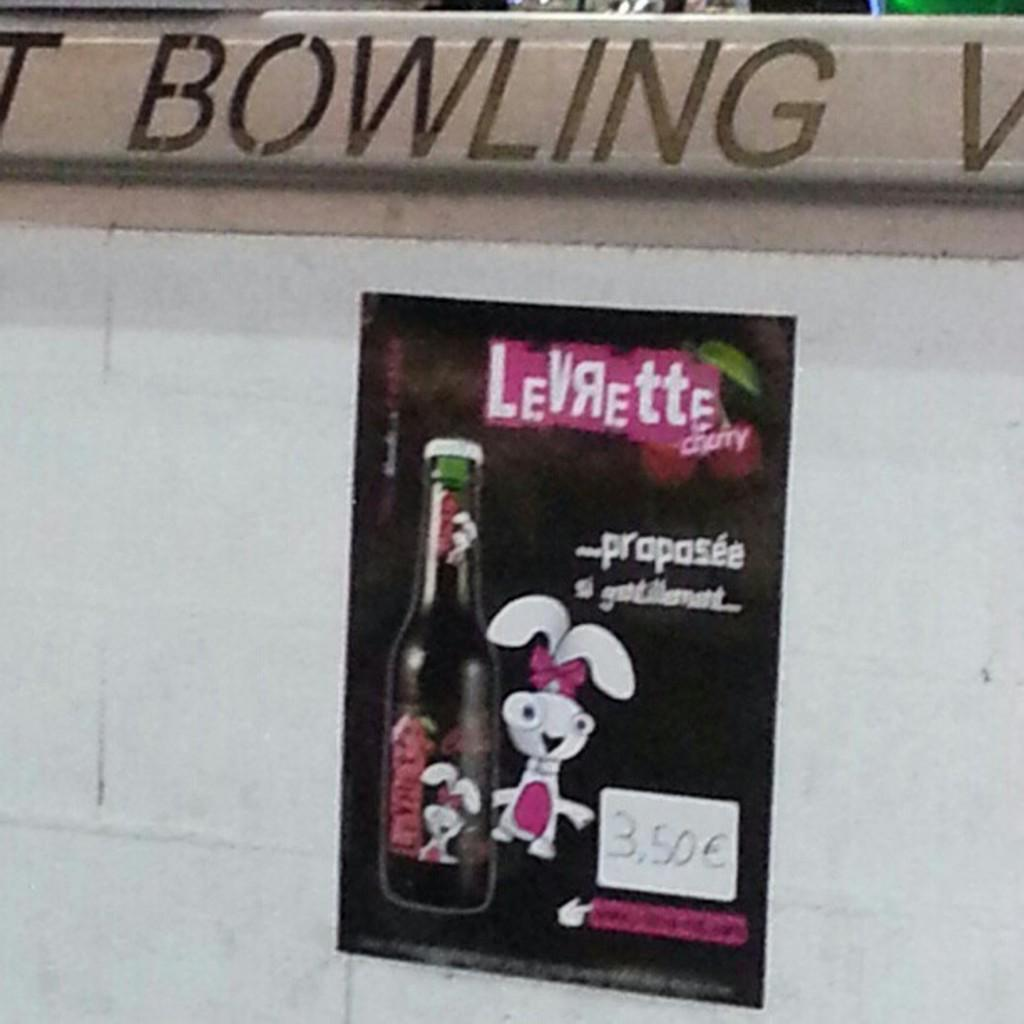<image>
Present a compact description of the photo's key features. An advertisement hanging in a bowling alley that has a rabbit holding a bottle of Levrette cherry cola. 